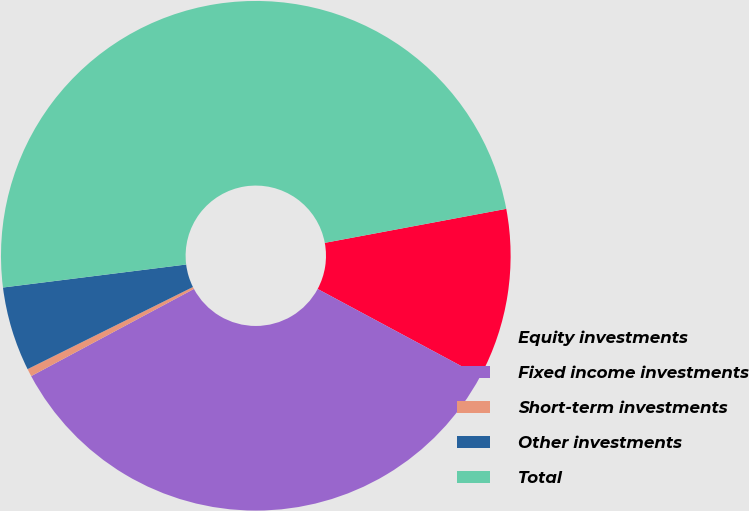Convert chart to OTSL. <chart><loc_0><loc_0><loc_500><loc_500><pie_chart><fcel>Equity investments<fcel>Fixed income investments<fcel>Short-term investments<fcel>Other investments<fcel>Total<nl><fcel>10.79%<fcel>34.33%<fcel>0.49%<fcel>5.35%<fcel>49.04%<nl></chart> 